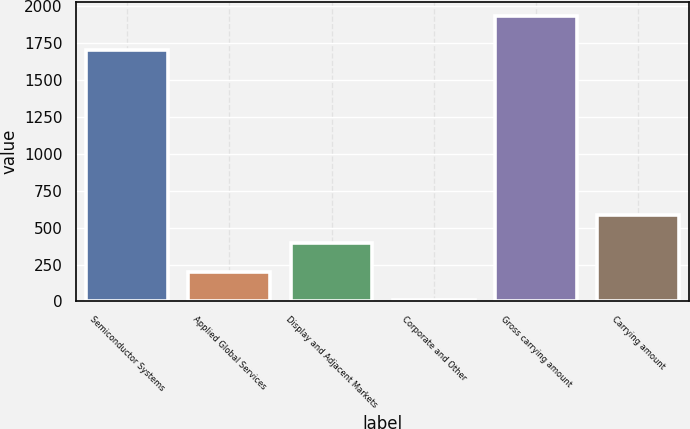<chart> <loc_0><loc_0><loc_500><loc_500><bar_chart><fcel>Semiconductor Systems<fcel>Applied Global Services<fcel>Display and Adjacent Markets<fcel>Corporate and Other<fcel>Gross carrying amount<fcel>Carrying amount<nl><fcel>1701<fcel>202.4<fcel>394.8<fcel>10<fcel>1934<fcel>587.2<nl></chart> 